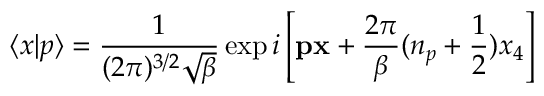Convert formula to latex. <formula><loc_0><loc_0><loc_500><loc_500>\langle x | p \rangle = \frac { 1 } ( 2 \pi ) ^ { 3 / 2 } \sqrt { \beta } } \exp i \left [ { p x } + \frac { 2 \pi } { \beta } ( n _ { p } + \frac { 1 } { 2 } ) x _ { 4 } \right ]</formula> 